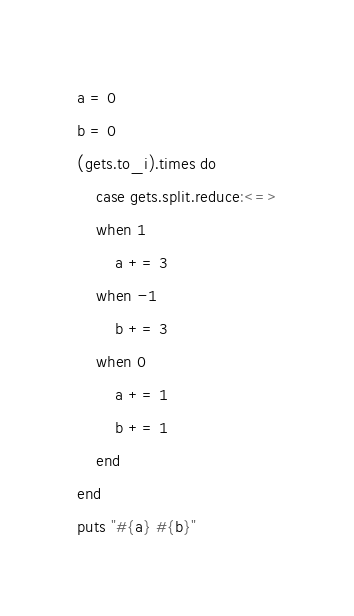<code> <loc_0><loc_0><loc_500><loc_500><_Ruby_>a = 0
b = 0
(gets.to_i).times do
	case gets.split.reduce:<=>
	when 1
		a += 3
	when -1
		b += 3
	when 0
		a += 1
		b += 1
	end
end
puts "#{a} #{b}"</code> 